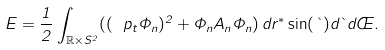<formula> <loc_0><loc_0><loc_500><loc_500>E = \frac { 1 } { 2 } \int _ { \mathbb { R } \times S ^ { 2 } } ( ( \ p _ { t } \Phi _ { n } ) ^ { 2 } + \Phi _ { n } A _ { n } \Phi _ { n } ) \, d r ^ { * } \sin ( \theta ) d \theta d \phi .</formula> 